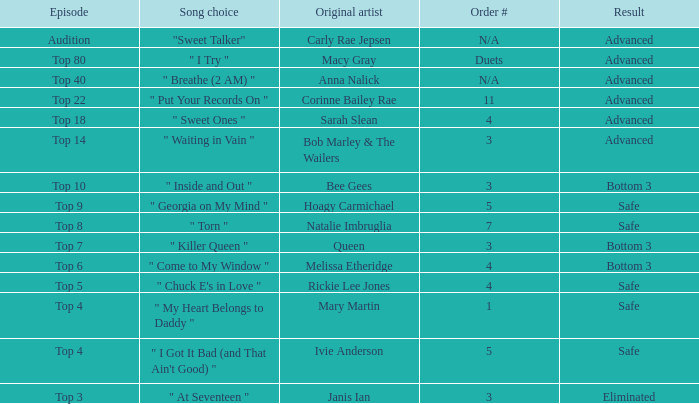What was the outcome of the top 3 episode? Eliminated. 